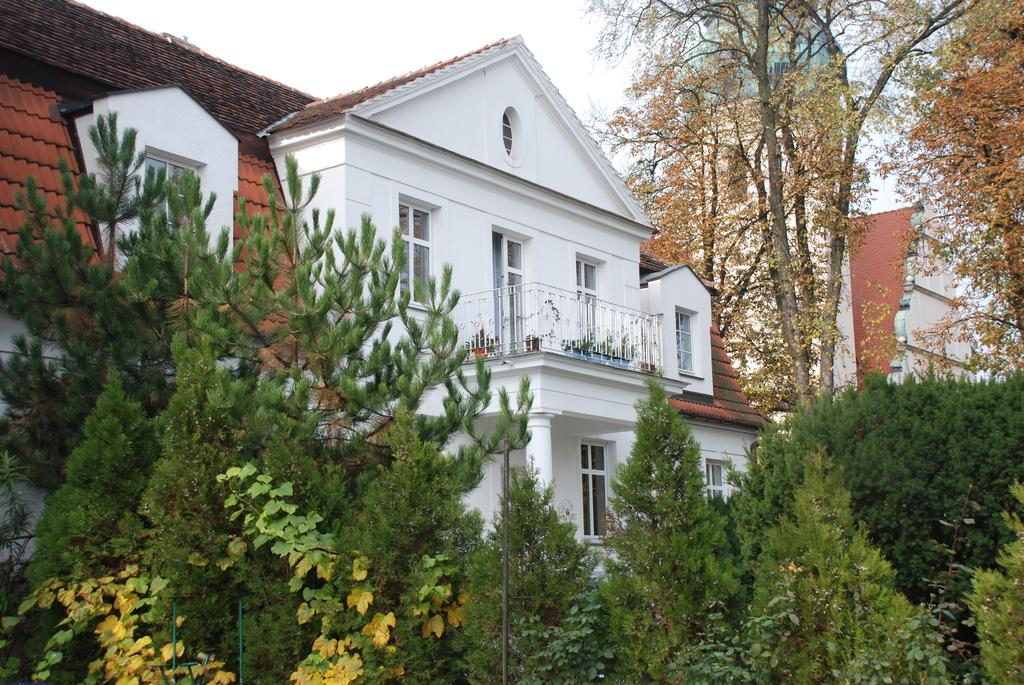What type of structures can be seen in the image? There are buildings in the image. What type of vegetation is present in the image? There are houseplants, trees, and bushes in the image. What is used for cooking in the image? There is a grill in the image. What part of the natural environment is visible in the image? The sky is visible in the image. What type of man-made objects can be seen in the image? There are poles in the image. Can you tell me how many balloons are tied to the grill in the image? There are no balloons present in the image. What type of shade is provided by the trees in the image? There is no mention of shade in the image; it only states that trees are present. 